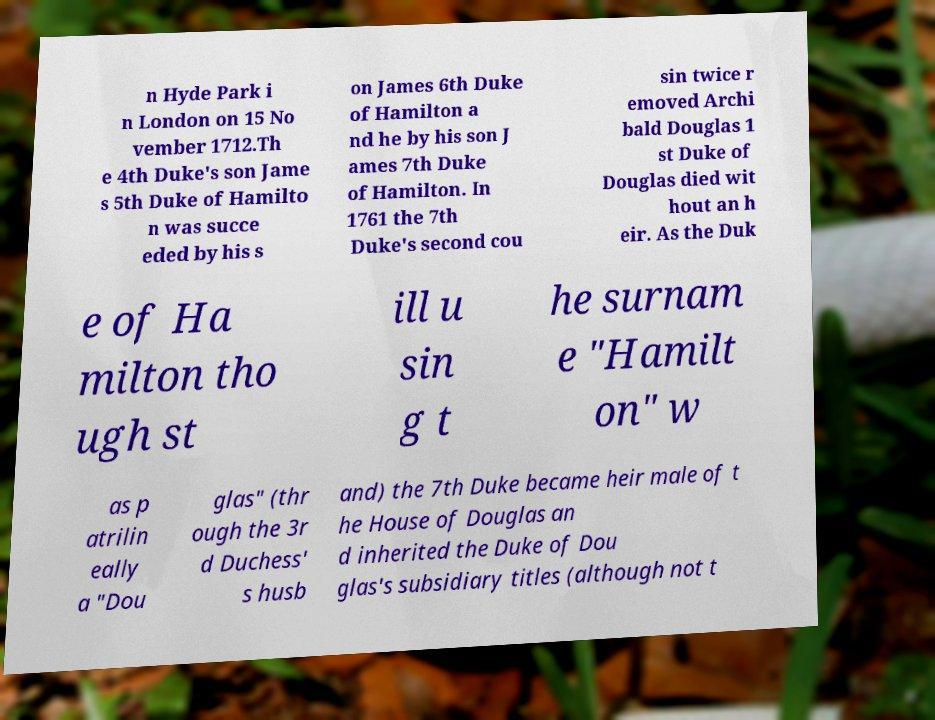Please read and relay the text visible in this image. What does it say? n Hyde Park i n London on 15 No vember 1712.Th e 4th Duke's son Jame s 5th Duke of Hamilto n was succe eded by his s on James 6th Duke of Hamilton a nd he by his son J ames 7th Duke of Hamilton. In 1761 the 7th Duke's second cou sin twice r emoved Archi bald Douglas 1 st Duke of Douglas died wit hout an h eir. As the Duk e of Ha milton tho ugh st ill u sin g t he surnam e "Hamilt on" w as p atrilin eally a "Dou glas" (thr ough the 3r d Duchess' s husb and) the 7th Duke became heir male of t he House of Douglas an d inherited the Duke of Dou glas's subsidiary titles (although not t 